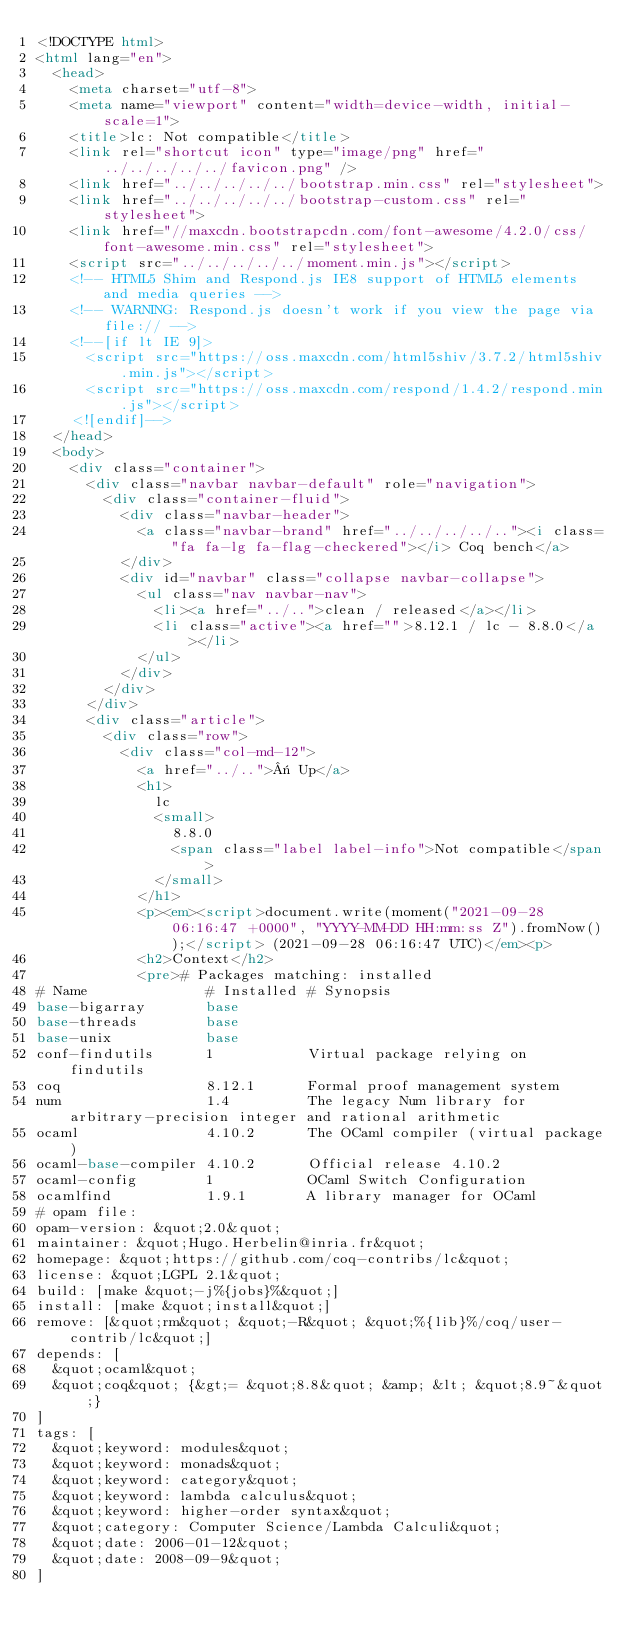Convert code to text. <code><loc_0><loc_0><loc_500><loc_500><_HTML_><!DOCTYPE html>
<html lang="en">
  <head>
    <meta charset="utf-8">
    <meta name="viewport" content="width=device-width, initial-scale=1">
    <title>lc: Not compatible</title>
    <link rel="shortcut icon" type="image/png" href="../../../../../favicon.png" />
    <link href="../../../../../bootstrap.min.css" rel="stylesheet">
    <link href="../../../../../bootstrap-custom.css" rel="stylesheet">
    <link href="//maxcdn.bootstrapcdn.com/font-awesome/4.2.0/css/font-awesome.min.css" rel="stylesheet">
    <script src="../../../../../moment.min.js"></script>
    <!-- HTML5 Shim and Respond.js IE8 support of HTML5 elements and media queries -->
    <!-- WARNING: Respond.js doesn't work if you view the page via file:// -->
    <!--[if lt IE 9]>
      <script src="https://oss.maxcdn.com/html5shiv/3.7.2/html5shiv.min.js"></script>
      <script src="https://oss.maxcdn.com/respond/1.4.2/respond.min.js"></script>
    <![endif]-->
  </head>
  <body>
    <div class="container">
      <div class="navbar navbar-default" role="navigation">
        <div class="container-fluid">
          <div class="navbar-header">
            <a class="navbar-brand" href="../../../../.."><i class="fa fa-lg fa-flag-checkered"></i> Coq bench</a>
          </div>
          <div id="navbar" class="collapse navbar-collapse">
            <ul class="nav navbar-nav">
              <li><a href="../..">clean / released</a></li>
              <li class="active"><a href="">8.12.1 / lc - 8.8.0</a></li>
            </ul>
          </div>
        </div>
      </div>
      <div class="article">
        <div class="row">
          <div class="col-md-12">
            <a href="../..">« Up</a>
            <h1>
              lc
              <small>
                8.8.0
                <span class="label label-info">Not compatible</span>
              </small>
            </h1>
            <p><em><script>document.write(moment("2021-09-28 06:16:47 +0000", "YYYY-MM-DD HH:mm:ss Z").fromNow());</script> (2021-09-28 06:16:47 UTC)</em><p>
            <h2>Context</h2>
            <pre># Packages matching: installed
# Name              # Installed # Synopsis
base-bigarray       base
base-threads        base
base-unix           base
conf-findutils      1           Virtual package relying on findutils
coq                 8.12.1      Formal proof management system
num                 1.4         The legacy Num library for arbitrary-precision integer and rational arithmetic
ocaml               4.10.2      The OCaml compiler (virtual package)
ocaml-base-compiler 4.10.2      Official release 4.10.2
ocaml-config        1           OCaml Switch Configuration
ocamlfind           1.9.1       A library manager for OCaml
# opam file:
opam-version: &quot;2.0&quot;
maintainer: &quot;Hugo.Herbelin@inria.fr&quot;
homepage: &quot;https://github.com/coq-contribs/lc&quot;
license: &quot;LGPL 2.1&quot;
build: [make &quot;-j%{jobs}%&quot;]
install: [make &quot;install&quot;]
remove: [&quot;rm&quot; &quot;-R&quot; &quot;%{lib}%/coq/user-contrib/lc&quot;]
depends: [
  &quot;ocaml&quot;
  &quot;coq&quot; {&gt;= &quot;8.8&quot; &amp; &lt; &quot;8.9~&quot;}
]
tags: [
  &quot;keyword: modules&quot;
  &quot;keyword: monads&quot;
  &quot;keyword: category&quot;
  &quot;keyword: lambda calculus&quot;
  &quot;keyword: higher-order syntax&quot;
  &quot;category: Computer Science/Lambda Calculi&quot;
  &quot;date: 2006-01-12&quot;
  &quot;date: 2008-09-9&quot;
]</code> 